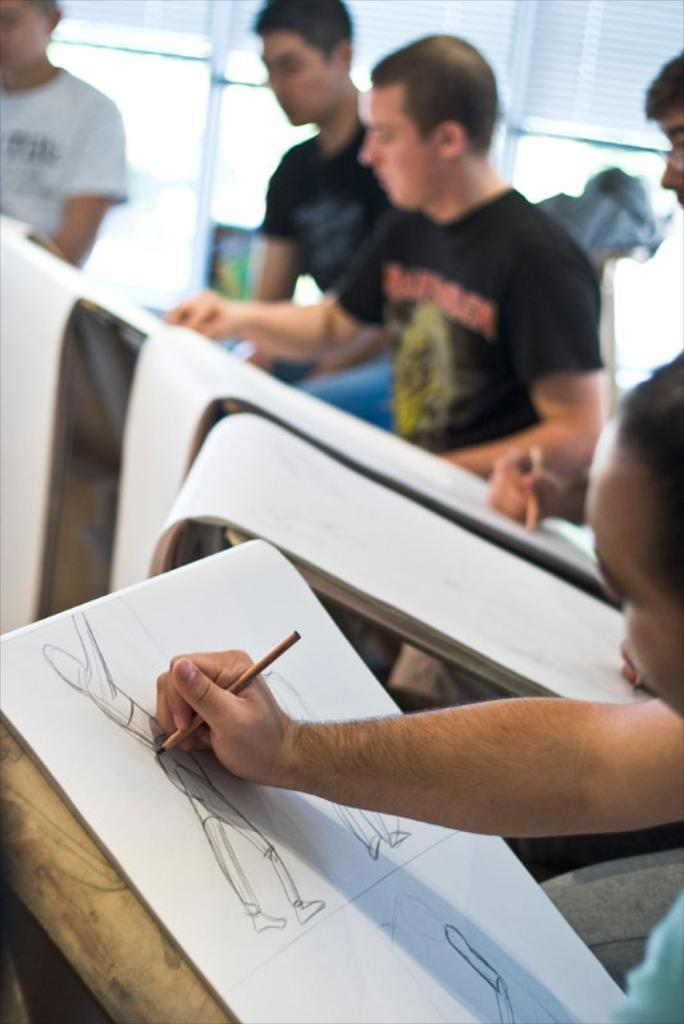Who or what is present in the image? There are people in the image. What are the people doing in the image? The people are drawing on white color sheets. What tools are the people using for drawing? The people are holding pencils. What are the people focusing on while drawing? The people are looking at the sheets. What can be seen in the background of the image? There is a window in the background of the image. Can you tell me how many crows are sitting on the clover in the image? There are no crows or clover present in the image; it features people drawing on white color sheets. 